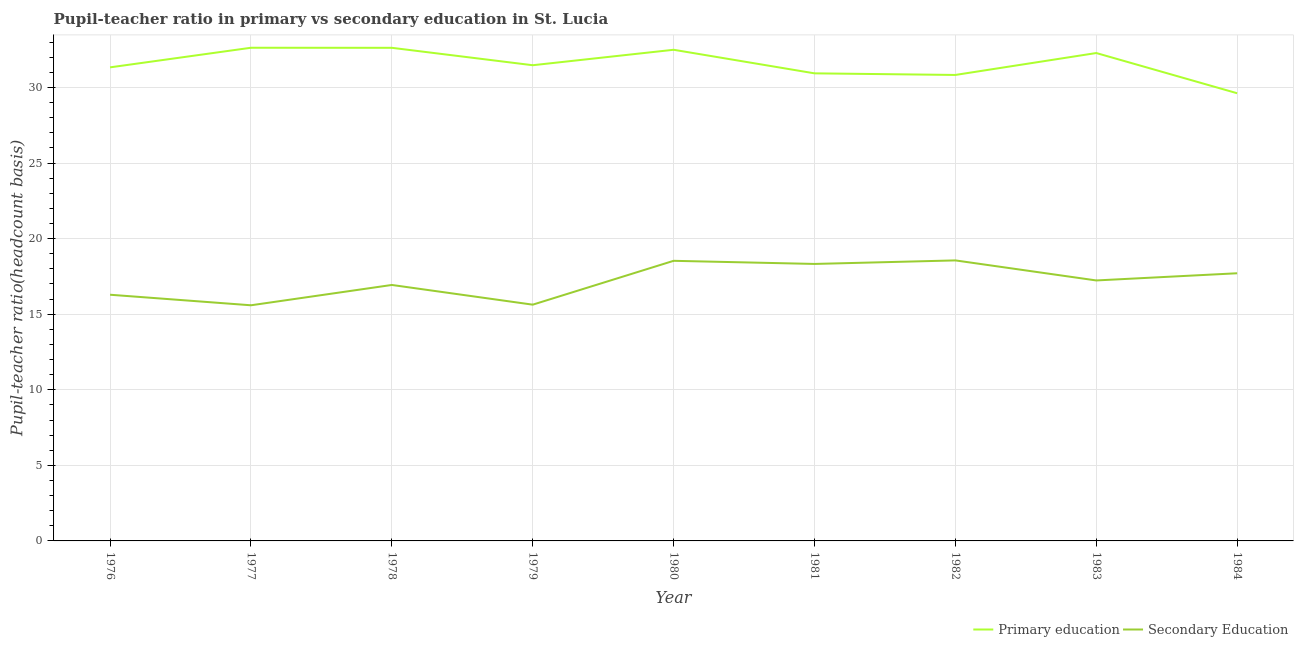Does the line corresponding to pupil-teacher ratio in primary education intersect with the line corresponding to pupil teacher ratio on secondary education?
Ensure brevity in your answer.  No. Is the number of lines equal to the number of legend labels?
Your answer should be compact. Yes. What is the pupil teacher ratio on secondary education in 1983?
Offer a very short reply. 17.23. Across all years, what is the maximum pupil teacher ratio on secondary education?
Provide a short and direct response. 18.56. Across all years, what is the minimum pupil teacher ratio on secondary education?
Provide a short and direct response. 15.59. In which year was the pupil-teacher ratio in primary education minimum?
Your answer should be very brief. 1984. What is the total pupil teacher ratio on secondary education in the graph?
Your answer should be very brief. 154.8. What is the difference between the pupil-teacher ratio in primary education in 1981 and that in 1983?
Offer a very short reply. -1.34. What is the difference between the pupil-teacher ratio in primary education in 1979 and the pupil teacher ratio on secondary education in 1982?
Your answer should be compact. 12.91. What is the average pupil-teacher ratio in primary education per year?
Offer a terse response. 31.58. In the year 1982, what is the difference between the pupil teacher ratio on secondary education and pupil-teacher ratio in primary education?
Keep it short and to the point. -12.27. What is the ratio of the pupil teacher ratio on secondary education in 1976 to that in 1978?
Offer a terse response. 0.96. What is the difference between the highest and the second highest pupil teacher ratio on secondary education?
Keep it short and to the point. 0.03. What is the difference between the highest and the lowest pupil-teacher ratio in primary education?
Offer a terse response. 3.01. Is the sum of the pupil teacher ratio on secondary education in 1979 and 1980 greater than the maximum pupil-teacher ratio in primary education across all years?
Offer a terse response. Yes. Does the pupil teacher ratio on secondary education monotonically increase over the years?
Offer a terse response. No. Is the pupil teacher ratio on secondary education strictly greater than the pupil-teacher ratio in primary education over the years?
Keep it short and to the point. No. How many lines are there?
Your response must be concise. 2. How many years are there in the graph?
Your answer should be very brief. 9. What is the difference between two consecutive major ticks on the Y-axis?
Keep it short and to the point. 5. Are the values on the major ticks of Y-axis written in scientific E-notation?
Your answer should be very brief. No. Does the graph contain grids?
Ensure brevity in your answer.  Yes. Where does the legend appear in the graph?
Offer a very short reply. Bottom right. How are the legend labels stacked?
Your response must be concise. Horizontal. What is the title of the graph?
Offer a very short reply. Pupil-teacher ratio in primary vs secondary education in St. Lucia. Does "Merchandise exports" appear as one of the legend labels in the graph?
Give a very brief answer. No. What is the label or title of the Y-axis?
Offer a terse response. Pupil-teacher ratio(headcount basis). What is the Pupil-teacher ratio(headcount basis) of Primary education in 1976?
Your response must be concise. 31.33. What is the Pupil-teacher ratio(headcount basis) of Secondary Education in 1976?
Provide a short and direct response. 16.29. What is the Pupil-teacher ratio(headcount basis) of Primary education in 1977?
Give a very brief answer. 32.63. What is the Pupil-teacher ratio(headcount basis) in Secondary Education in 1977?
Offer a very short reply. 15.59. What is the Pupil-teacher ratio(headcount basis) of Primary education in 1978?
Offer a very short reply. 32.62. What is the Pupil-teacher ratio(headcount basis) in Secondary Education in 1978?
Give a very brief answer. 16.93. What is the Pupil-teacher ratio(headcount basis) of Primary education in 1979?
Offer a very short reply. 31.47. What is the Pupil-teacher ratio(headcount basis) in Secondary Education in 1979?
Offer a very short reply. 15.63. What is the Pupil-teacher ratio(headcount basis) in Primary education in 1980?
Give a very brief answer. 32.49. What is the Pupil-teacher ratio(headcount basis) in Secondary Education in 1980?
Make the answer very short. 18.53. What is the Pupil-teacher ratio(headcount basis) in Primary education in 1981?
Provide a short and direct response. 30.94. What is the Pupil-teacher ratio(headcount basis) in Secondary Education in 1981?
Make the answer very short. 18.32. What is the Pupil-teacher ratio(headcount basis) in Primary education in 1982?
Provide a succinct answer. 30.83. What is the Pupil-teacher ratio(headcount basis) in Secondary Education in 1982?
Make the answer very short. 18.56. What is the Pupil-teacher ratio(headcount basis) of Primary education in 1983?
Provide a succinct answer. 32.28. What is the Pupil-teacher ratio(headcount basis) of Secondary Education in 1983?
Your answer should be compact. 17.23. What is the Pupil-teacher ratio(headcount basis) of Primary education in 1984?
Offer a terse response. 29.62. What is the Pupil-teacher ratio(headcount basis) of Secondary Education in 1984?
Your answer should be very brief. 17.71. Across all years, what is the maximum Pupil-teacher ratio(headcount basis) in Primary education?
Your answer should be compact. 32.63. Across all years, what is the maximum Pupil-teacher ratio(headcount basis) in Secondary Education?
Your answer should be compact. 18.56. Across all years, what is the minimum Pupil-teacher ratio(headcount basis) of Primary education?
Your answer should be compact. 29.62. Across all years, what is the minimum Pupil-teacher ratio(headcount basis) in Secondary Education?
Your answer should be compact. 15.59. What is the total Pupil-teacher ratio(headcount basis) in Primary education in the graph?
Your response must be concise. 284.21. What is the total Pupil-teacher ratio(headcount basis) of Secondary Education in the graph?
Make the answer very short. 154.8. What is the difference between the Pupil-teacher ratio(headcount basis) of Primary education in 1976 and that in 1977?
Make the answer very short. -1.3. What is the difference between the Pupil-teacher ratio(headcount basis) in Secondary Education in 1976 and that in 1977?
Give a very brief answer. 0.7. What is the difference between the Pupil-teacher ratio(headcount basis) in Primary education in 1976 and that in 1978?
Give a very brief answer. -1.29. What is the difference between the Pupil-teacher ratio(headcount basis) of Secondary Education in 1976 and that in 1978?
Offer a terse response. -0.65. What is the difference between the Pupil-teacher ratio(headcount basis) of Primary education in 1976 and that in 1979?
Offer a terse response. -0.14. What is the difference between the Pupil-teacher ratio(headcount basis) of Secondary Education in 1976 and that in 1979?
Your response must be concise. 0.66. What is the difference between the Pupil-teacher ratio(headcount basis) in Primary education in 1976 and that in 1980?
Provide a succinct answer. -1.16. What is the difference between the Pupil-teacher ratio(headcount basis) in Secondary Education in 1976 and that in 1980?
Give a very brief answer. -2.24. What is the difference between the Pupil-teacher ratio(headcount basis) in Primary education in 1976 and that in 1981?
Your answer should be compact. 0.4. What is the difference between the Pupil-teacher ratio(headcount basis) of Secondary Education in 1976 and that in 1981?
Ensure brevity in your answer.  -2.04. What is the difference between the Pupil-teacher ratio(headcount basis) in Primary education in 1976 and that in 1982?
Provide a succinct answer. 0.5. What is the difference between the Pupil-teacher ratio(headcount basis) in Secondary Education in 1976 and that in 1982?
Your response must be concise. -2.27. What is the difference between the Pupil-teacher ratio(headcount basis) of Primary education in 1976 and that in 1983?
Ensure brevity in your answer.  -0.95. What is the difference between the Pupil-teacher ratio(headcount basis) of Secondary Education in 1976 and that in 1983?
Make the answer very short. -0.95. What is the difference between the Pupil-teacher ratio(headcount basis) of Primary education in 1976 and that in 1984?
Your answer should be very brief. 1.71. What is the difference between the Pupil-teacher ratio(headcount basis) of Secondary Education in 1976 and that in 1984?
Ensure brevity in your answer.  -1.42. What is the difference between the Pupil-teacher ratio(headcount basis) in Primary education in 1977 and that in 1978?
Give a very brief answer. 0. What is the difference between the Pupil-teacher ratio(headcount basis) in Secondary Education in 1977 and that in 1978?
Your response must be concise. -1.34. What is the difference between the Pupil-teacher ratio(headcount basis) in Primary education in 1977 and that in 1979?
Make the answer very short. 1.16. What is the difference between the Pupil-teacher ratio(headcount basis) in Secondary Education in 1977 and that in 1979?
Your response must be concise. -0.04. What is the difference between the Pupil-teacher ratio(headcount basis) in Primary education in 1977 and that in 1980?
Ensure brevity in your answer.  0.13. What is the difference between the Pupil-teacher ratio(headcount basis) in Secondary Education in 1977 and that in 1980?
Provide a succinct answer. -2.94. What is the difference between the Pupil-teacher ratio(headcount basis) of Primary education in 1977 and that in 1981?
Keep it short and to the point. 1.69. What is the difference between the Pupil-teacher ratio(headcount basis) in Secondary Education in 1977 and that in 1981?
Your response must be concise. -2.73. What is the difference between the Pupil-teacher ratio(headcount basis) in Primary education in 1977 and that in 1982?
Your response must be concise. 1.8. What is the difference between the Pupil-teacher ratio(headcount basis) in Secondary Education in 1977 and that in 1982?
Your answer should be very brief. -2.97. What is the difference between the Pupil-teacher ratio(headcount basis) of Primary education in 1977 and that in 1983?
Your response must be concise. 0.35. What is the difference between the Pupil-teacher ratio(headcount basis) in Secondary Education in 1977 and that in 1983?
Your answer should be compact. -1.64. What is the difference between the Pupil-teacher ratio(headcount basis) of Primary education in 1977 and that in 1984?
Offer a very short reply. 3.01. What is the difference between the Pupil-teacher ratio(headcount basis) of Secondary Education in 1977 and that in 1984?
Provide a short and direct response. -2.12. What is the difference between the Pupil-teacher ratio(headcount basis) in Primary education in 1978 and that in 1979?
Your answer should be very brief. 1.15. What is the difference between the Pupil-teacher ratio(headcount basis) of Secondary Education in 1978 and that in 1979?
Give a very brief answer. 1.3. What is the difference between the Pupil-teacher ratio(headcount basis) in Primary education in 1978 and that in 1980?
Your answer should be compact. 0.13. What is the difference between the Pupil-teacher ratio(headcount basis) of Secondary Education in 1978 and that in 1980?
Offer a terse response. -1.6. What is the difference between the Pupil-teacher ratio(headcount basis) of Primary education in 1978 and that in 1981?
Offer a terse response. 1.69. What is the difference between the Pupil-teacher ratio(headcount basis) of Secondary Education in 1978 and that in 1981?
Your answer should be very brief. -1.39. What is the difference between the Pupil-teacher ratio(headcount basis) of Primary education in 1978 and that in 1982?
Offer a very short reply. 1.8. What is the difference between the Pupil-teacher ratio(headcount basis) in Secondary Education in 1978 and that in 1982?
Make the answer very short. -1.62. What is the difference between the Pupil-teacher ratio(headcount basis) of Primary education in 1978 and that in 1983?
Give a very brief answer. 0.35. What is the difference between the Pupil-teacher ratio(headcount basis) in Secondary Education in 1978 and that in 1983?
Your response must be concise. -0.3. What is the difference between the Pupil-teacher ratio(headcount basis) of Primary education in 1978 and that in 1984?
Your answer should be compact. 3.01. What is the difference between the Pupil-teacher ratio(headcount basis) of Secondary Education in 1978 and that in 1984?
Give a very brief answer. -0.77. What is the difference between the Pupil-teacher ratio(headcount basis) of Primary education in 1979 and that in 1980?
Your answer should be very brief. -1.02. What is the difference between the Pupil-teacher ratio(headcount basis) of Secondary Education in 1979 and that in 1980?
Your answer should be compact. -2.9. What is the difference between the Pupil-teacher ratio(headcount basis) of Primary education in 1979 and that in 1981?
Provide a short and direct response. 0.54. What is the difference between the Pupil-teacher ratio(headcount basis) of Secondary Education in 1979 and that in 1981?
Make the answer very short. -2.69. What is the difference between the Pupil-teacher ratio(headcount basis) of Primary education in 1979 and that in 1982?
Provide a succinct answer. 0.64. What is the difference between the Pupil-teacher ratio(headcount basis) of Secondary Education in 1979 and that in 1982?
Provide a succinct answer. -2.93. What is the difference between the Pupil-teacher ratio(headcount basis) of Primary education in 1979 and that in 1983?
Ensure brevity in your answer.  -0.81. What is the difference between the Pupil-teacher ratio(headcount basis) in Secondary Education in 1979 and that in 1983?
Offer a terse response. -1.6. What is the difference between the Pupil-teacher ratio(headcount basis) in Primary education in 1979 and that in 1984?
Offer a very short reply. 1.85. What is the difference between the Pupil-teacher ratio(headcount basis) of Secondary Education in 1979 and that in 1984?
Your answer should be very brief. -2.08. What is the difference between the Pupil-teacher ratio(headcount basis) of Primary education in 1980 and that in 1981?
Provide a short and direct response. 1.56. What is the difference between the Pupil-teacher ratio(headcount basis) in Secondary Education in 1980 and that in 1981?
Your response must be concise. 0.21. What is the difference between the Pupil-teacher ratio(headcount basis) of Primary education in 1980 and that in 1982?
Your answer should be compact. 1.67. What is the difference between the Pupil-teacher ratio(headcount basis) of Secondary Education in 1980 and that in 1982?
Your answer should be very brief. -0.03. What is the difference between the Pupil-teacher ratio(headcount basis) in Primary education in 1980 and that in 1983?
Offer a very short reply. 0.22. What is the difference between the Pupil-teacher ratio(headcount basis) of Secondary Education in 1980 and that in 1983?
Offer a terse response. 1.3. What is the difference between the Pupil-teacher ratio(headcount basis) in Primary education in 1980 and that in 1984?
Keep it short and to the point. 2.88. What is the difference between the Pupil-teacher ratio(headcount basis) of Secondary Education in 1980 and that in 1984?
Your answer should be compact. 0.82. What is the difference between the Pupil-teacher ratio(headcount basis) of Primary education in 1981 and that in 1982?
Provide a succinct answer. 0.11. What is the difference between the Pupil-teacher ratio(headcount basis) of Secondary Education in 1981 and that in 1982?
Your answer should be very brief. -0.23. What is the difference between the Pupil-teacher ratio(headcount basis) in Primary education in 1981 and that in 1983?
Provide a succinct answer. -1.34. What is the difference between the Pupil-teacher ratio(headcount basis) in Secondary Education in 1981 and that in 1983?
Offer a terse response. 1.09. What is the difference between the Pupil-teacher ratio(headcount basis) in Primary education in 1981 and that in 1984?
Your answer should be very brief. 1.32. What is the difference between the Pupil-teacher ratio(headcount basis) in Secondary Education in 1981 and that in 1984?
Your answer should be compact. 0.62. What is the difference between the Pupil-teacher ratio(headcount basis) in Primary education in 1982 and that in 1983?
Your answer should be compact. -1.45. What is the difference between the Pupil-teacher ratio(headcount basis) in Secondary Education in 1982 and that in 1983?
Your answer should be very brief. 1.33. What is the difference between the Pupil-teacher ratio(headcount basis) in Primary education in 1982 and that in 1984?
Provide a short and direct response. 1.21. What is the difference between the Pupil-teacher ratio(headcount basis) in Secondary Education in 1982 and that in 1984?
Keep it short and to the point. 0.85. What is the difference between the Pupil-teacher ratio(headcount basis) in Primary education in 1983 and that in 1984?
Provide a short and direct response. 2.66. What is the difference between the Pupil-teacher ratio(headcount basis) in Secondary Education in 1983 and that in 1984?
Provide a succinct answer. -0.48. What is the difference between the Pupil-teacher ratio(headcount basis) in Primary education in 1976 and the Pupil-teacher ratio(headcount basis) in Secondary Education in 1977?
Your answer should be compact. 15.74. What is the difference between the Pupil-teacher ratio(headcount basis) of Primary education in 1976 and the Pupil-teacher ratio(headcount basis) of Secondary Education in 1978?
Offer a very short reply. 14.4. What is the difference between the Pupil-teacher ratio(headcount basis) in Primary education in 1976 and the Pupil-teacher ratio(headcount basis) in Secondary Education in 1979?
Keep it short and to the point. 15.7. What is the difference between the Pupil-teacher ratio(headcount basis) in Primary education in 1976 and the Pupil-teacher ratio(headcount basis) in Secondary Education in 1980?
Keep it short and to the point. 12.8. What is the difference between the Pupil-teacher ratio(headcount basis) in Primary education in 1976 and the Pupil-teacher ratio(headcount basis) in Secondary Education in 1981?
Keep it short and to the point. 13.01. What is the difference between the Pupil-teacher ratio(headcount basis) of Primary education in 1976 and the Pupil-teacher ratio(headcount basis) of Secondary Education in 1982?
Your answer should be compact. 12.77. What is the difference between the Pupil-teacher ratio(headcount basis) of Primary education in 1976 and the Pupil-teacher ratio(headcount basis) of Secondary Education in 1983?
Your answer should be compact. 14.1. What is the difference between the Pupil-teacher ratio(headcount basis) in Primary education in 1976 and the Pupil-teacher ratio(headcount basis) in Secondary Education in 1984?
Offer a terse response. 13.62. What is the difference between the Pupil-teacher ratio(headcount basis) of Primary education in 1977 and the Pupil-teacher ratio(headcount basis) of Secondary Education in 1978?
Offer a very short reply. 15.69. What is the difference between the Pupil-teacher ratio(headcount basis) in Primary education in 1977 and the Pupil-teacher ratio(headcount basis) in Secondary Education in 1979?
Provide a succinct answer. 17. What is the difference between the Pupil-teacher ratio(headcount basis) of Primary education in 1977 and the Pupil-teacher ratio(headcount basis) of Secondary Education in 1980?
Your answer should be compact. 14.1. What is the difference between the Pupil-teacher ratio(headcount basis) in Primary education in 1977 and the Pupil-teacher ratio(headcount basis) in Secondary Education in 1981?
Keep it short and to the point. 14.3. What is the difference between the Pupil-teacher ratio(headcount basis) of Primary education in 1977 and the Pupil-teacher ratio(headcount basis) of Secondary Education in 1982?
Ensure brevity in your answer.  14.07. What is the difference between the Pupil-teacher ratio(headcount basis) of Primary education in 1977 and the Pupil-teacher ratio(headcount basis) of Secondary Education in 1983?
Your answer should be very brief. 15.4. What is the difference between the Pupil-teacher ratio(headcount basis) in Primary education in 1977 and the Pupil-teacher ratio(headcount basis) in Secondary Education in 1984?
Your response must be concise. 14.92. What is the difference between the Pupil-teacher ratio(headcount basis) of Primary education in 1978 and the Pupil-teacher ratio(headcount basis) of Secondary Education in 1979?
Provide a short and direct response. 16.99. What is the difference between the Pupil-teacher ratio(headcount basis) in Primary education in 1978 and the Pupil-teacher ratio(headcount basis) in Secondary Education in 1980?
Your answer should be very brief. 14.09. What is the difference between the Pupil-teacher ratio(headcount basis) in Primary education in 1978 and the Pupil-teacher ratio(headcount basis) in Secondary Education in 1981?
Offer a terse response. 14.3. What is the difference between the Pupil-teacher ratio(headcount basis) in Primary education in 1978 and the Pupil-teacher ratio(headcount basis) in Secondary Education in 1982?
Ensure brevity in your answer.  14.07. What is the difference between the Pupil-teacher ratio(headcount basis) of Primary education in 1978 and the Pupil-teacher ratio(headcount basis) of Secondary Education in 1983?
Keep it short and to the point. 15.39. What is the difference between the Pupil-teacher ratio(headcount basis) in Primary education in 1978 and the Pupil-teacher ratio(headcount basis) in Secondary Education in 1984?
Ensure brevity in your answer.  14.92. What is the difference between the Pupil-teacher ratio(headcount basis) of Primary education in 1979 and the Pupil-teacher ratio(headcount basis) of Secondary Education in 1980?
Your answer should be very brief. 12.94. What is the difference between the Pupil-teacher ratio(headcount basis) in Primary education in 1979 and the Pupil-teacher ratio(headcount basis) in Secondary Education in 1981?
Provide a short and direct response. 13.15. What is the difference between the Pupil-teacher ratio(headcount basis) in Primary education in 1979 and the Pupil-teacher ratio(headcount basis) in Secondary Education in 1982?
Your answer should be compact. 12.91. What is the difference between the Pupil-teacher ratio(headcount basis) in Primary education in 1979 and the Pupil-teacher ratio(headcount basis) in Secondary Education in 1983?
Your answer should be compact. 14.24. What is the difference between the Pupil-teacher ratio(headcount basis) in Primary education in 1979 and the Pupil-teacher ratio(headcount basis) in Secondary Education in 1984?
Provide a short and direct response. 13.76. What is the difference between the Pupil-teacher ratio(headcount basis) of Primary education in 1980 and the Pupil-teacher ratio(headcount basis) of Secondary Education in 1981?
Your response must be concise. 14.17. What is the difference between the Pupil-teacher ratio(headcount basis) of Primary education in 1980 and the Pupil-teacher ratio(headcount basis) of Secondary Education in 1982?
Your response must be concise. 13.94. What is the difference between the Pupil-teacher ratio(headcount basis) of Primary education in 1980 and the Pupil-teacher ratio(headcount basis) of Secondary Education in 1983?
Give a very brief answer. 15.26. What is the difference between the Pupil-teacher ratio(headcount basis) of Primary education in 1980 and the Pupil-teacher ratio(headcount basis) of Secondary Education in 1984?
Give a very brief answer. 14.79. What is the difference between the Pupil-teacher ratio(headcount basis) in Primary education in 1981 and the Pupil-teacher ratio(headcount basis) in Secondary Education in 1982?
Offer a terse response. 12.38. What is the difference between the Pupil-teacher ratio(headcount basis) in Primary education in 1981 and the Pupil-teacher ratio(headcount basis) in Secondary Education in 1983?
Your response must be concise. 13.7. What is the difference between the Pupil-teacher ratio(headcount basis) in Primary education in 1981 and the Pupil-teacher ratio(headcount basis) in Secondary Education in 1984?
Ensure brevity in your answer.  13.23. What is the difference between the Pupil-teacher ratio(headcount basis) of Primary education in 1982 and the Pupil-teacher ratio(headcount basis) of Secondary Education in 1983?
Provide a short and direct response. 13.6. What is the difference between the Pupil-teacher ratio(headcount basis) in Primary education in 1982 and the Pupil-teacher ratio(headcount basis) in Secondary Education in 1984?
Your answer should be compact. 13.12. What is the difference between the Pupil-teacher ratio(headcount basis) of Primary education in 1983 and the Pupil-teacher ratio(headcount basis) of Secondary Education in 1984?
Give a very brief answer. 14.57. What is the average Pupil-teacher ratio(headcount basis) of Primary education per year?
Provide a short and direct response. 31.58. What is the average Pupil-teacher ratio(headcount basis) of Secondary Education per year?
Provide a succinct answer. 17.2. In the year 1976, what is the difference between the Pupil-teacher ratio(headcount basis) in Primary education and Pupil-teacher ratio(headcount basis) in Secondary Education?
Your response must be concise. 15.04. In the year 1977, what is the difference between the Pupil-teacher ratio(headcount basis) of Primary education and Pupil-teacher ratio(headcount basis) of Secondary Education?
Make the answer very short. 17.04. In the year 1978, what is the difference between the Pupil-teacher ratio(headcount basis) of Primary education and Pupil-teacher ratio(headcount basis) of Secondary Education?
Make the answer very short. 15.69. In the year 1979, what is the difference between the Pupil-teacher ratio(headcount basis) in Primary education and Pupil-teacher ratio(headcount basis) in Secondary Education?
Keep it short and to the point. 15.84. In the year 1980, what is the difference between the Pupil-teacher ratio(headcount basis) of Primary education and Pupil-teacher ratio(headcount basis) of Secondary Education?
Ensure brevity in your answer.  13.96. In the year 1981, what is the difference between the Pupil-teacher ratio(headcount basis) of Primary education and Pupil-teacher ratio(headcount basis) of Secondary Education?
Provide a succinct answer. 12.61. In the year 1982, what is the difference between the Pupil-teacher ratio(headcount basis) of Primary education and Pupil-teacher ratio(headcount basis) of Secondary Education?
Your answer should be compact. 12.27. In the year 1983, what is the difference between the Pupil-teacher ratio(headcount basis) in Primary education and Pupil-teacher ratio(headcount basis) in Secondary Education?
Keep it short and to the point. 15.05. In the year 1984, what is the difference between the Pupil-teacher ratio(headcount basis) in Primary education and Pupil-teacher ratio(headcount basis) in Secondary Education?
Ensure brevity in your answer.  11.91. What is the ratio of the Pupil-teacher ratio(headcount basis) of Primary education in 1976 to that in 1977?
Keep it short and to the point. 0.96. What is the ratio of the Pupil-teacher ratio(headcount basis) of Secondary Education in 1976 to that in 1977?
Your answer should be very brief. 1.04. What is the ratio of the Pupil-teacher ratio(headcount basis) in Primary education in 1976 to that in 1978?
Give a very brief answer. 0.96. What is the ratio of the Pupil-teacher ratio(headcount basis) of Secondary Education in 1976 to that in 1978?
Your response must be concise. 0.96. What is the ratio of the Pupil-teacher ratio(headcount basis) of Primary education in 1976 to that in 1979?
Keep it short and to the point. 1. What is the ratio of the Pupil-teacher ratio(headcount basis) of Secondary Education in 1976 to that in 1979?
Make the answer very short. 1.04. What is the ratio of the Pupil-teacher ratio(headcount basis) in Primary education in 1976 to that in 1980?
Your answer should be very brief. 0.96. What is the ratio of the Pupil-teacher ratio(headcount basis) of Secondary Education in 1976 to that in 1980?
Ensure brevity in your answer.  0.88. What is the ratio of the Pupil-teacher ratio(headcount basis) in Primary education in 1976 to that in 1981?
Provide a short and direct response. 1.01. What is the ratio of the Pupil-teacher ratio(headcount basis) of Secondary Education in 1976 to that in 1981?
Keep it short and to the point. 0.89. What is the ratio of the Pupil-teacher ratio(headcount basis) in Primary education in 1976 to that in 1982?
Provide a short and direct response. 1.02. What is the ratio of the Pupil-teacher ratio(headcount basis) in Secondary Education in 1976 to that in 1982?
Your answer should be compact. 0.88. What is the ratio of the Pupil-teacher ratio(headcount basis) of Primary education in 1976 to that in 1983?
Provide a short and direct response. 0.97. What is the ratio of the Pupil-teacher ratio(headcount basis) of Secondary Education in 1976 to that in 1983?
Provide a succinct answer. 0.95. What is the ratio of the Pupil-teacher ratio(headcount basis) of Primary education in 1976 to that in 1984?
Offer a terse response. 1.06. What is the ratio of the Pupil-teacher ratio(headcount basis) of Secondary Education in 1976 to that in 1984?
Make the answer very short. 0.92. What is the ratio of the Pupil-teacher ratio(headcount basis) in Primary education in 1977 to that in 1978?
Provide a short and direct response. 1. What is the ratio of the Pupil-teacher ratio(headcount basis) in Secondary Education in 1977 to that in 1978?
Offer a terse response. 0.92. What is the ratio of the Pupil-teacher ratio(headcount basis) in Primary education in 1977 to that in 1979?
Your response must be concise. 1.04. What is the ratio of the Pupil-teacher ratio(headcount basis) of Secondary Education in 1977 to that in 1979?
Offer a very short reply. 1. What is the ratio of the Pupil-teacher ratio(headcount basis) of Primary education in 1977 to that in 1980?
Your response must be concise. 1. What is the ratio of the Pupil-teacher ratio(headcount basis) in Secondary Education in 1977 to that in 1980?
Provide a short and direct response. 0.84. What is the ratio of the Pupil-teacher ratio(headcount basis) in Primary education in 1977 to that in 1981?
Your answer should be compact. 1.05. What is the ratio of the Pupil-teacher ratio(headcount basis) in Secondary Education in 1977 to that in 1981?
Provide a succinct answer. 0.85. What is the ratio of the Pupil-teacher ratio(headcount basis) of Primary education in 1977 to that in 1982?
Provide a succinct answer. 1.06. What is the ratio of the Pupil-teacher ratio(headcount basis) of Secondary Education in 1977 to that in 1982?
Offer a terse response. 0.84. What is the ratio of the Pupil-teacher ratio(headcount basis) of Primary education in 1977 to that in 1983?
Provide a short and direct response. 1.01. What is the ratio of the Pupil-teacher ratio(headcount basis) in Secondary Education in 1977 to that in 1983?
Provide a short and direct response. 0.9. What is the ratio of the Pupil-teacher ratio(headcount basis) in Primary education in 1977 to that in 1984?
Your answer should be compact. 1.1. What is the ratio of the Pupil-teacher ratio(headcount basis) of Secondary Education in 1977 to that in 1984?
Your answer should be very brief. 0.88. What is the ratio of the Pupil-teacher ratio(headcount basis) in Primary education in 1978 to that in 1979?
Offer a very short reply. 1.04. What is the ratio of the Pupil-teacher ratio(headcount basis) of Secondary Education in 1978 to that in 1979?
Your answer should be compact. 1.08. What is the ratio of the Pupil-teacher ratio(headcount basis) in Primary education in 1978 to that in 1980?
Make the answer very short. 1. What is the ratio of the Pupil-teacher ratio(headcount basis) of Secondary Education in 1978 to that in 1980?
Offer a terse response. 0.91. What is the ratio of the Pupil-teacher ratio(headcount basis) of Primary education in 1978 to that in 1981?
Your answer should be very brief. 1.05. What is the ratio of the Pupil-teacher ratio(headcount basis) of Secondary Education in 1978 to that in 1981?
Offer a terse response. 0.92. What is the ratio of the Pupil-teacher ratio(headcount basis) in Primary education in 1978 to that in 1982?
Offer a terse response. 1.06. What is the ratio of the Pupil-teacher ratio(headcount basis) in Secondary Education in 1978 to that in 1982?
Your answer should be very brief. 0.91. What is the ratio of the Pupil-teacher ratio(headcount basis) of Primary education in 1978 to that in 1983?
Keep it short and to the point. 1.01. What is the ratio of the Pupil-teacher ratio(headcount basis) in Secondary Education in 1978 to that in 1983?
Make the answer very short. 0.98. What is the ratio of the Pupil-teacher ratio(headcount basis) of Primary education in 1978 to that in 1984?
Provide a succinct answer. 1.1. What is the ratio of the Pupil-teacher ratio(headcount basis) of Secondary Education in 1978 to that in 1984?
Your response must be concise. 0.96. What is the ratio of the Pupil-teacher ratio(headcount basis) of Primary education in 1979 to that in 1980?
Ensure brevity in your answer.  0.97. What is the ratio of the Pupil-teacher ratio(headcount basis) of Secondary Education in 1979 to that in 1980?
Your answer should be compact. 0.84. What is the ratio of the Pupil-teacher ratio(headcount basis) in Primary education in 1979 to that in 1981?
Your response must be concise. 1.02. What is the ratio of the Pupil-teacher ratio(headcount basis) of Secondary Education in 1979 to that in 1981?
Make the answer very short. 0.85. What is the ratio of the Pupil-teacher ratio(headcount basis) of Primary education in 1979 to that in 1982?
Keep it short and to the point. 1.02. What is the ratio of the Pupil-teacher ratio(headcount basis) of Secondary Education in 1979 to that in 1982?
Ensure brevity in your answer.  0.84. What is the ratio of the Pupil-teacher ratio(headcount basis) of Secondary Education in 1979 to that in 1983?
Your answer should be compact. 0.91. What is the ratio of the Pupil-teacher ratio(headcount basis) of Primary education in 1979 to that in 1984?
Your answer should be compact. 1.06. What is the ratio of the Pupil-teacher ratio(headcount basis) in Secondary Education in 1979 to that in 1984?
Provide a succinct answer. 0.88. What is the ratio of the Pupil-teacher ratio(headcount basis) in Primary education in 1980 to that in 1981?
Make the answer very short. 1.05. What is the ratio of the Pupil-teacher ratio(headcount basis) in Secondary Education in 1980 to that in 1981?
Keep it short and to the point. 1.01. What is the ratio of the Pupil-teacher ratio(headcount basis) in Primary education in 1980 to that in 1982?
Offer a very short reply. 1.05. What is the ratio of the Pupil-teacher ratio(headcount basis) of Secondary Education in 1980 to that in 1982?
Your answer should be very brief. 1. What is the ratio of the Pupil-teacher ratio(headcount basis) in Primary education in 1980 to that in 1983?
Make the answer very short. 1.01. What is the ratio of the Pupil-teacher ratio(headcount basis) of Secondary Education in 1980 to that in 1983?
Give a very brief answer. 1.08. What is the ratio of the Pupil-teacher ratio(headcount basis) in Primary education in 1980 to that in 1984?
Offer a very short reply. 1.1. What is the ratio of the Pupil-teacher ratio(headcount basis) in Secondary Education in 1980 to that in 1984?
Ensure brevity in your answer.  1.05. What is the ratio of the Pupil-teacher ratio(headcount basis) in Secondary Education in 1981 to that in 1982?
Offer a terse response. 0.99. What is the ratio of the Pupil-teacher ratio(headcount basis) in Primary education in 1981 to that in 1983?
Ensure brevity in your answer.  0.96. What is the ratio of the Pupil-teacher ratio(headcount basis) in Secondary Education in 1981 to that in 1983?
Make the answer very short. 1.06. What is the ratio of the Pupil-teacher ratio(headcount basis) of Primary education in 1981 to that in 1984?
Your answer should be compact. 1.04. What is the ratio of the Pupil-teacher ratio(headcount basis) of Secondary Education in 1981 to that in 1984?
Keep it short and to the point. 1.03. What is the ratio of the Pupil-teacher ratio(headcount basis) in Primary education in 1982 to that in 1983?
Your response must be concise. 0.96. What is the ratio of the Pupil-teacher ratio(headcount basis) in Secondary Education in 1982 to that in 1983?
Make the answer very short. 1.08. What is the ratio of the Pupil-teacher ratio(headcount basis) of Primary education in 1982 to that in 1984?
Offer a terse response. 1.04. What is the ratio of the Pupil-teacher ratio(headcount basis) in Secondary Education in 1982 to that in 1984?
Keep it short and to the point. 1.05. What is the ratio of the Pupil-teacher ratio(headcount basis) of Primary education in 1983 to that in 1984?
Keep it short and to the point. 1.09. What is the ratio of the Pupil-teacher ratio(headcount basis) in Secondary Education in 1983 to that in 1984?
Provide a short and direct response. 0.97. What is the difference between the highest and the second highest Pupil-teacher ratio(headcount basis) of Primary education?
Provide a short and direct response. 0. What is the difference between the highest and the second highest Pupil-teacher ratio(headcount basis) of Secondary Education?
Provide a short and direct response. 0.03. What is the difference between the highest and the lowest Pupil-teacher ratio(headcount basis) in Primary education?
Your response must be concise. 3.01. What is the difference between the highest and the lowest Pupil-teacher ratio(headcount basis) in Secondary Education?
Your answer should be compact. 2.97. 